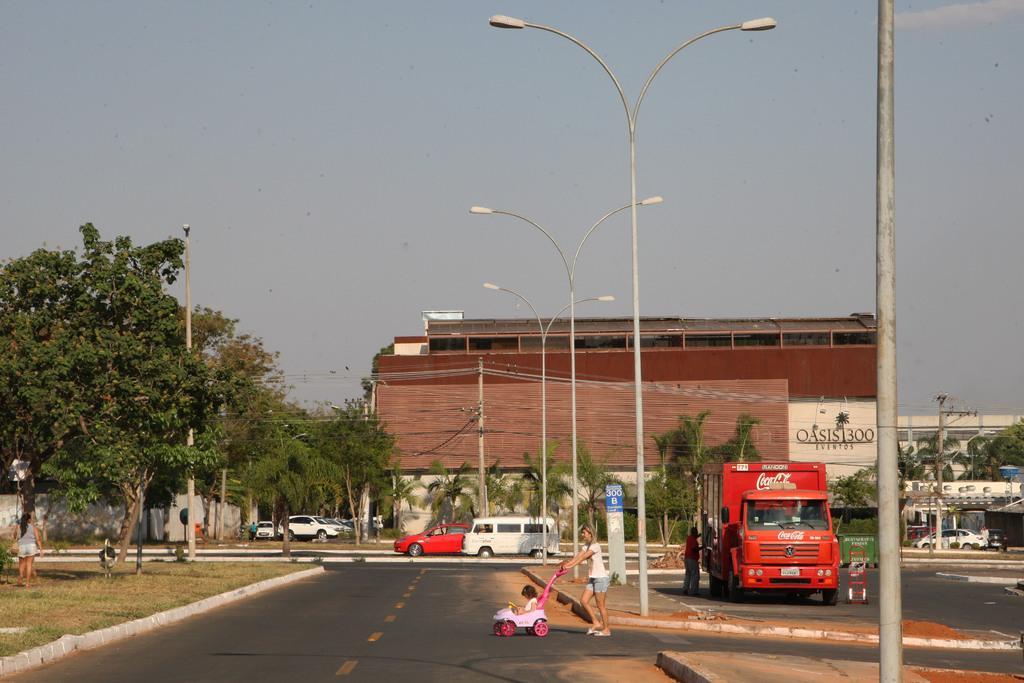In one or two sentences, can you explain what this image depicts? In this picture we can see a child in a stroller and a woman on the road, here we can see electric poles with lights, vehicles, people, trees, buildings and some objects and we can see sky in the background. 